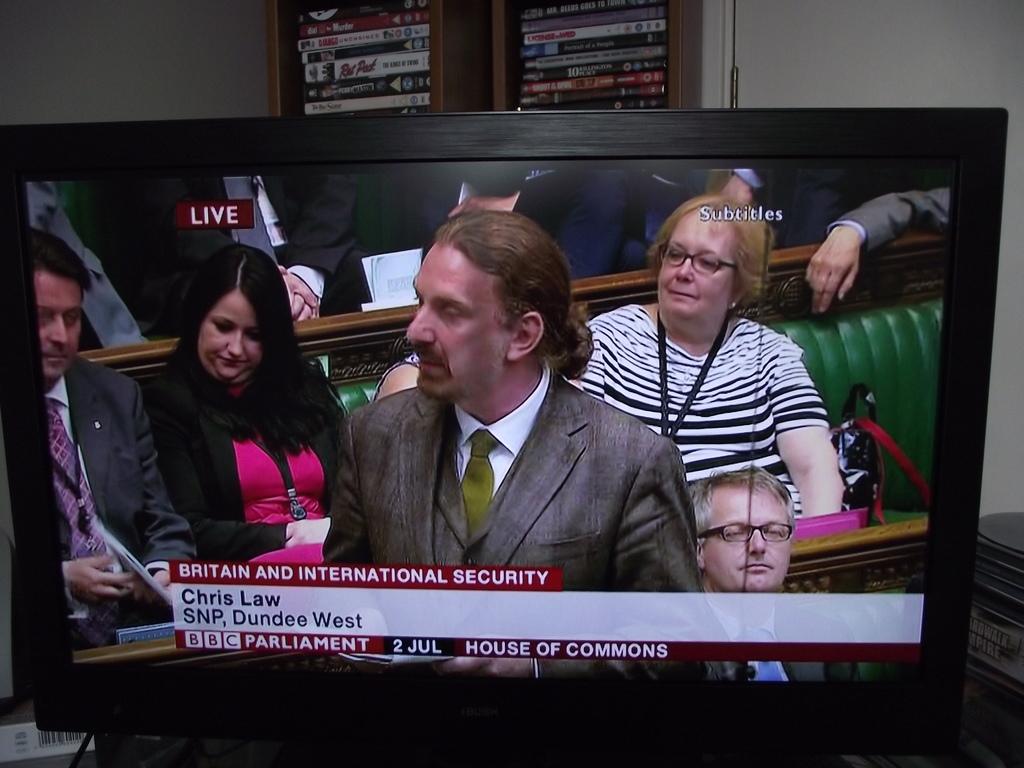Where does chris law work?
Provide a succinct answer. Dundee west. What channel is this on?
Your response must be concise. Bbc. 